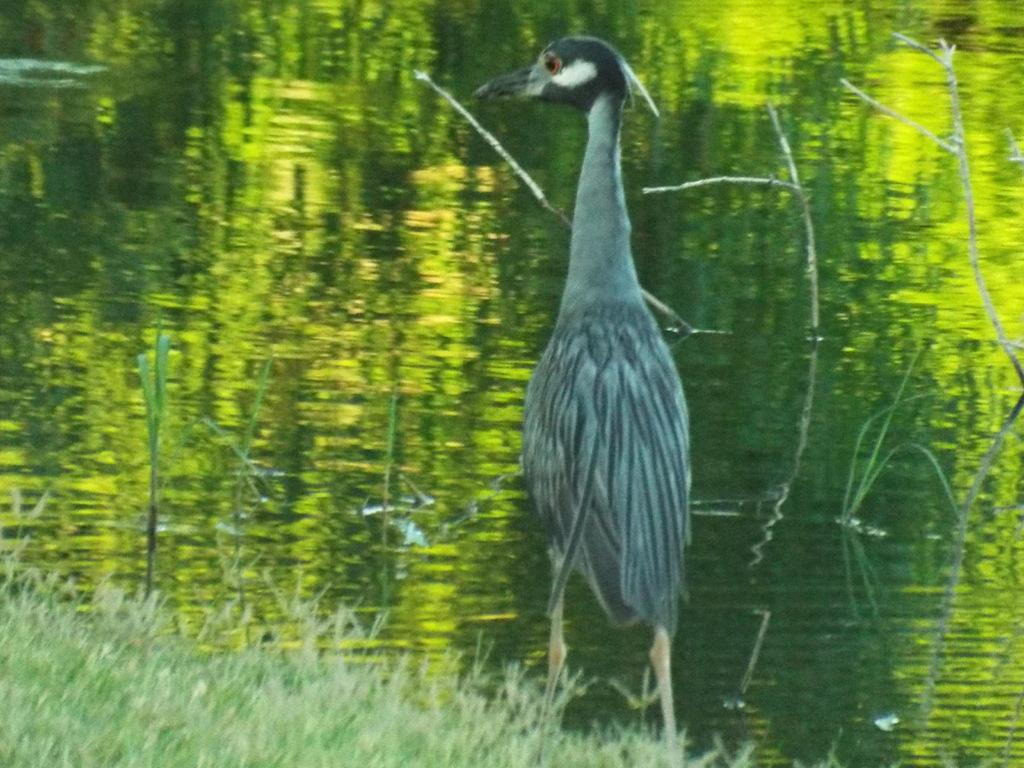In one or two sentences, can you explain what this image depicts? In this image in the front there's grass on the ground and in the center there is a bird standing. In the background there is water. 